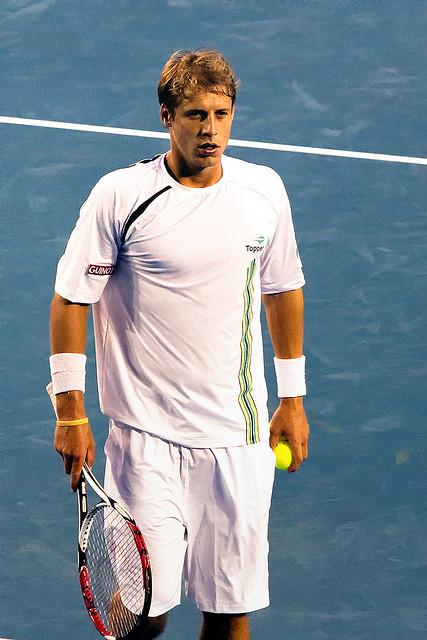Why does he have his forearms wrapped? sweat 